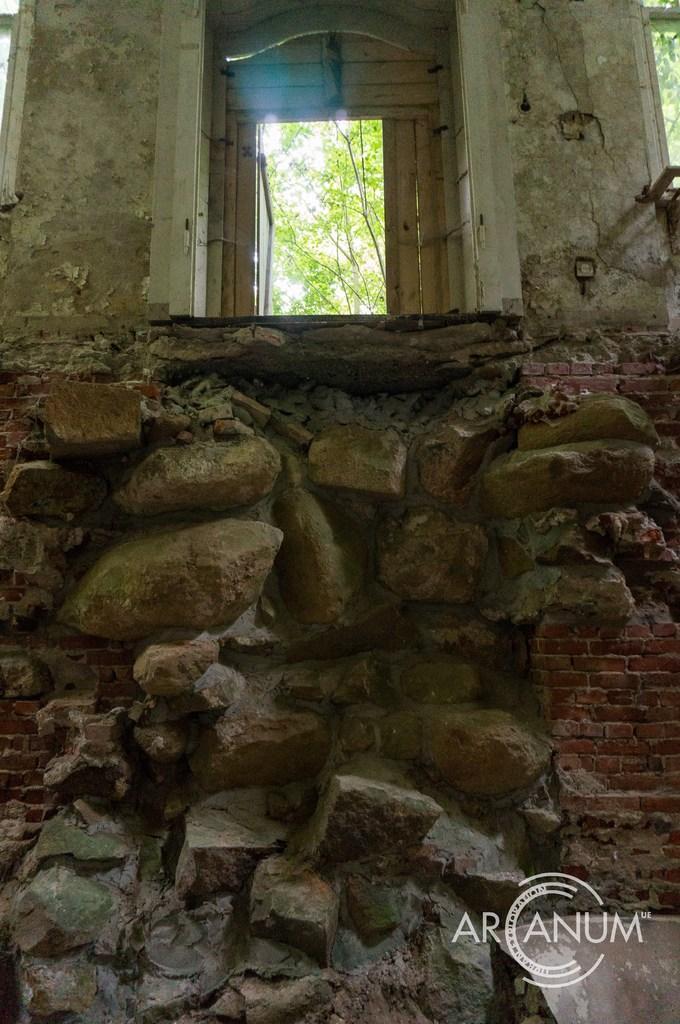Can you describe this image briefly? In this picture, in the foreground we can see the stone wall and on the right there is a red color brick wall. On the top we can see the doors and trees. On the bottom right corner there is a watermark on the image. 